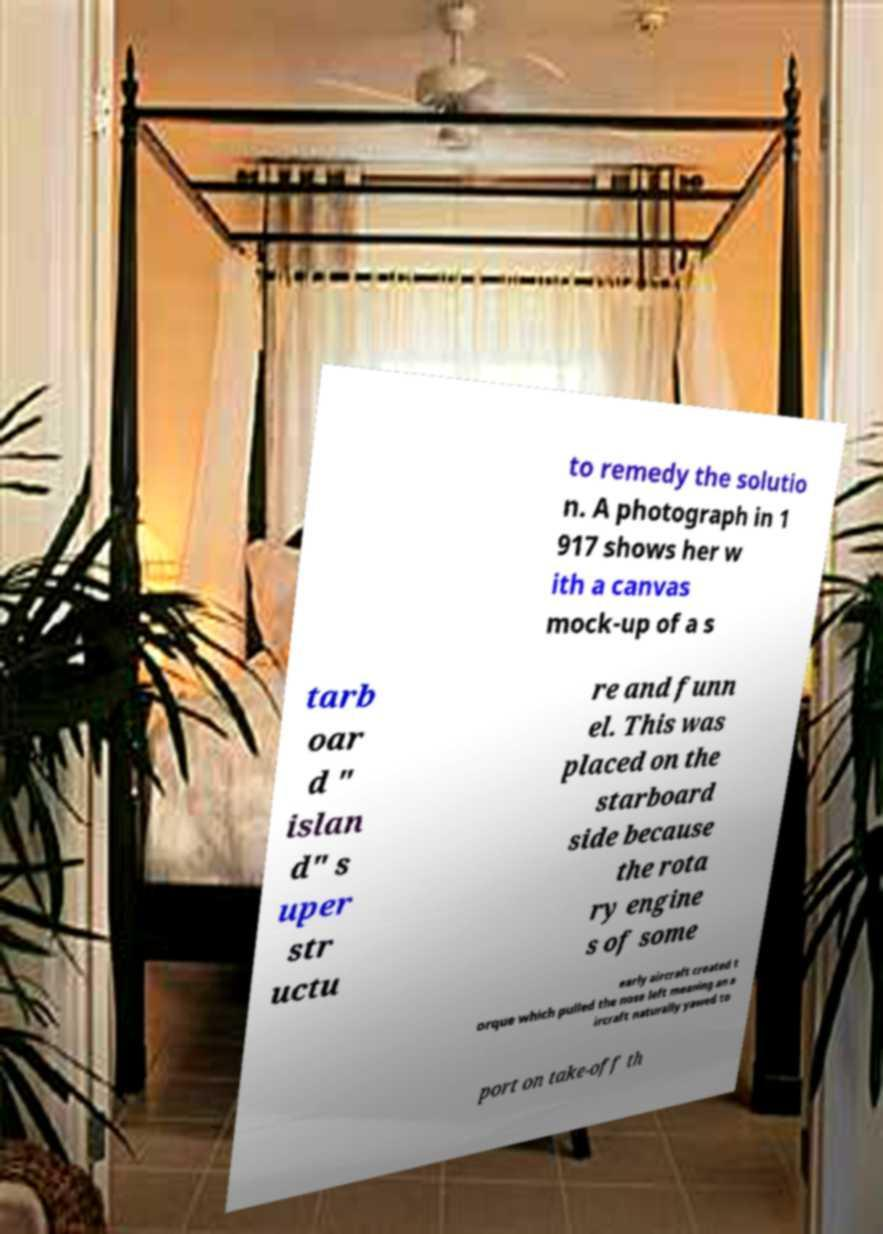Please read and relay the text visible in this image. What does it say? to remedy the solutio n. A photograph in 1 917 shows her w ith a canvas mock-up of a s tarb oar d " islan d" s uper str uctu re and funn el. This was placed on the starboard side because the rota ry engine s of some early aircraft created t orque which pulled the nose left meaning an a ircraft naturally yawed to port on take-off th 